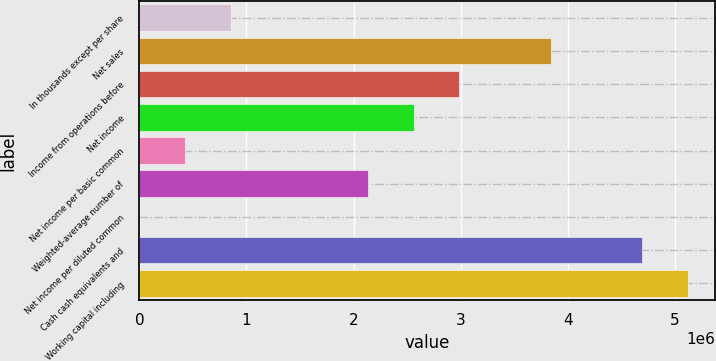<chart> <loc_0><loc_0><loc_500><loc_500><bar_chart><fcel>In thousands except per share<fcel>Net sales<fcel>Income from operations before<fcel>Net income<fcel>Net income per basic common<fcel>Weighted-average number of<fcel>Net income per diluted common<fcel>Cash cash equivalents and<fcel>Working capital including<nl><fcel>853740<fcel>3.84181e+06<fcel>2.98808e+06<fcel>2.56121e+06<fcel>426873<fcel>2.13434e+06<fcel>5.65<fcel>4.69554e+06<fcel>5.12241e+06<nl></chart> 